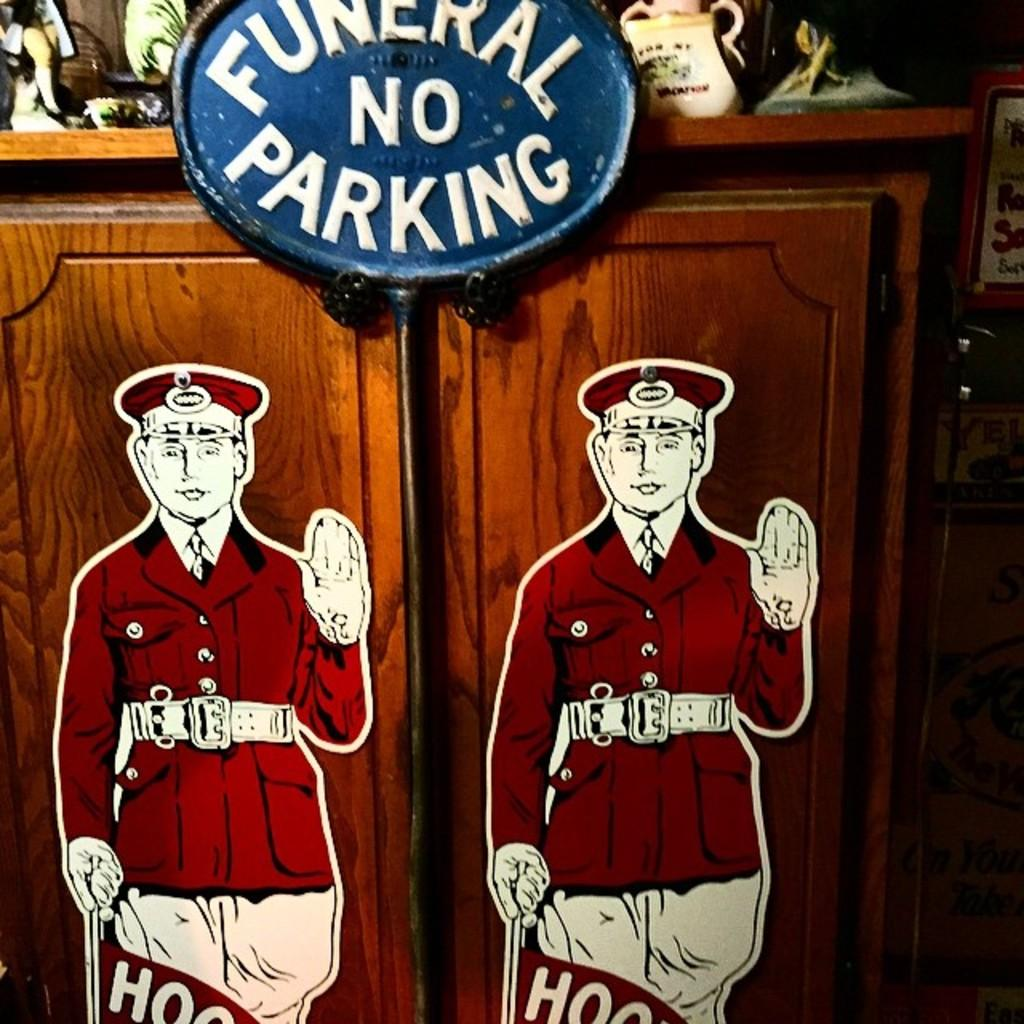<image>
Offer a succinct explanation of the picture presented. A blue sign above a cupboard that says funeral no parking 